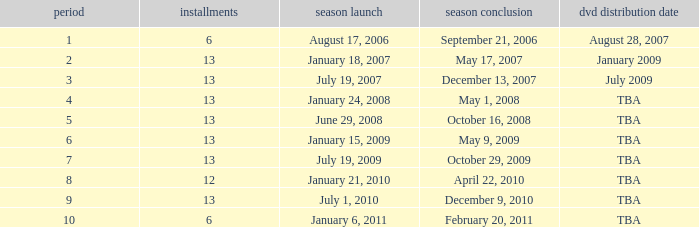On what date was the DVD released for the season with fewer than 13 episodes that aired before season 8? August 28, 2007. 